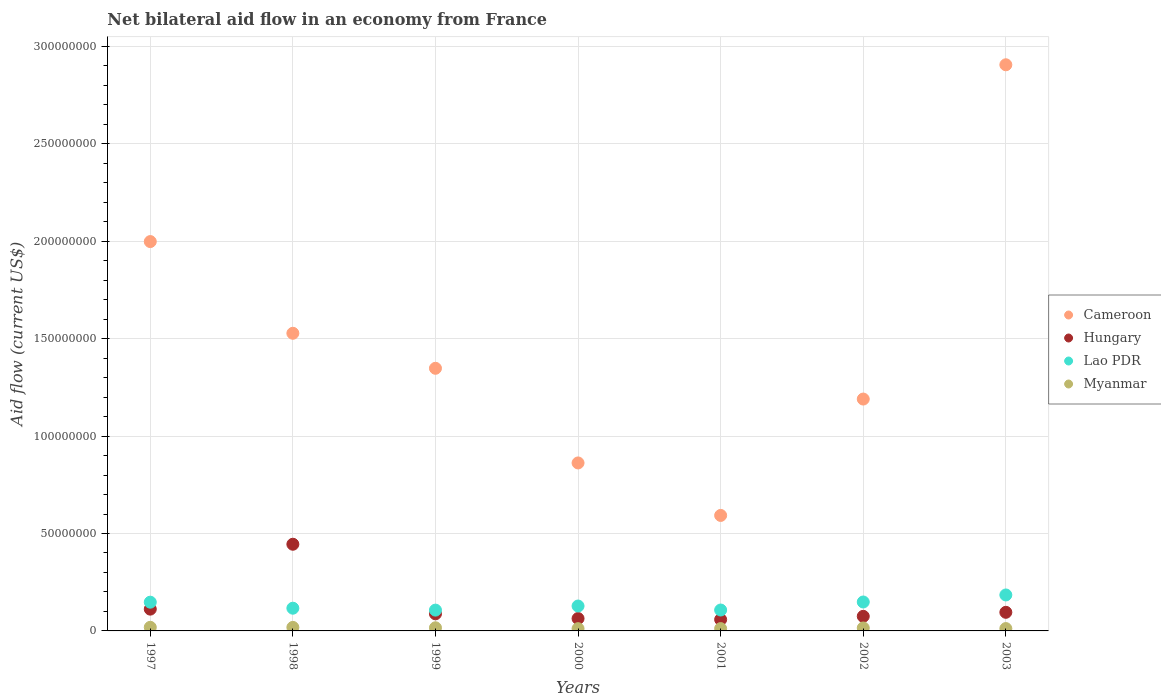How many different coloured dotlines are there?
Your answer should be compact. 4. Is the number of dotlines equal to the number of legend labels?
Your answer should be very brief. Yes. What is the net bilateral aid flow in Cameroon in 2003?
Keep it short and to the point. 2.91e+08. Across all years, what is the maximum net bilateral aid flow in Hungary?
Give a very brief answer. 4.45e+07. Across all years, what is the minimum net bilateral aid flow in Myanmar?
Offer a very short reply. 1.16e+06. What is the total net bilateral aid flow in Lao PDR in the graph?
Make the answer very short. 9.39e+07. What is the difference between the net bilateral aid flow in Hungary in 2001 and that in 2003?
Offer a terse response. -3.71e+06. What is the difference between the net bilateral aid flow in Cameroon in 1998 and the net bilateral aid flow in Hungary in 2000?
Ensure brevity in your answer.  1.46e+08. What is the average net bilateral aid flow in Cameroon per year?
Your answer should be compact. 1.49e+08. In the year 1997, what is the difference between the net bilateral aid flow in Myanmar and net bilateral aid flow in Cameroon?
Provide a short and direct response. -1.98e+08. What is the ratio of the net bilateral aid flow in Hungary in 1997 to that in 2000?
Offer a terse response. 1.76. What is the difference between the highest and the lowest net bilateral aid flow in Cameroon?
Make the answer very short. 2.31e+08. In how many years, is the net bilateral aid flow in Cameroon greater than the average net bilateral aid flow in Cameroon taken over all years?
Give a very brief answer. 3. Is it the case that in every year, the sum of the net bilateral aid flow in Lao PDR and net bilateral aid flow in Cameroon  is greater than the net bilateral aid flow in Myanmar?
Offer a terse response. Yes. Does the net bilateral aid flow in Hungary monotonically increase over the years?
Provide a succinct answer. No. Is the net bilateral aid flow in Lao PDR strictly greater than the net bilateral aid flow in Hungary over the years?
Keep it short and to the point. No. How many dotlines are there?
Keep it short and to the point. 4. Does the graph contain any zero values?
Your answer should be compact. No. Does the graph contain grids?
Make the answer very short. Yes. How many legend labels are there?
Give a very brief answer. 4. What is the title of the graph?
Your answer should be very brief. Net bilateral aid flow in an economy from France. What is the label or title of the X-axis?
Your answer should be very brief. Years. What is the label or title of the Y-axis?
Give a very brief answer. Aid flow (current US$). What is the Aid flow (current US$) in Cameroon in 1997?
Offer a very short reply. 2.00e+08. What is the Aid flow (current US$) of Hungary in 1997?
Provide a short and direct response. 1.12e+07. What is the Aid flow (current US$) in Lao PDR in 1997?
Your answer should be very brief. 1.48e+07. What is the Aid flow (current US$) of Myanmar in 1997?
Offer a terse response. 1.85e+06. What is the Aid flow (current US$) in Cameroon in 1998?
Offer a very short reply. 1.53e+08. What is the Aid flow (current US$) of Hungary in 1998?
Offer a terse response. 4.45e+07. What is the Aid flow (current US$) in Lao PDR in 1998?
Give a very brief answer. 1.17e+07. What is the Aid flow (current US$) in Myanmar in 1998?
Your response must be concise. 1.81e+06. What is the Aid flow (current US$) in Cameroon in 1999?
Your response must be concise. 1.35e+08. What is the Aid flow (current US$) in Hungary in 1999?
Keep it short and to the point. 8.77e+06. What is the Aid flow (current US$) in Lao PDR in 1999?
Provide a short and direct response. 1.07e+07. What is the Aid flow (current US$) in Myanmar in 1999?
Provide a short and direct response. 1.61e+06. What is the Aid flow (current US$) in Cameroon in 2000?
Your answer should be very brief. 8.62e+07. What is the Aid flow (current US$) in Hungary in 2000?
Offer a terse response. 6.36e+06. What is the Aid flow (current US$) of Lao PDR in 2000?
Provide a short and direct response. 1.28e+07. What is the Aid flow (current US$) of Myanmar in 2000?
Provide a short and direct response. 1.16e+06. What is the Aid flow (current US$) in Cameroon in 2001?
Your answer should be compact. 5.93e+07. What is the Aid flow (current US$) in Hungary in 2001?
Ensure brevity in your answer.  5.84e+06. What is the Aid flow (current US$) of Lao PDR in 2001?
Offer a terse response. 1.07e+07. What is the Aid flow (current US$) of Myanmar in 2001?
Offer a terse response. 1.19e+06. What is the Aid flow (current US$) of Cameroon in 2002?
Keep it short and to the point. 1.19e+08. What is the Aid flow (current US$) of Hungary in 2002?
Provide a succinct answer. 7.49e+06. What is the Aid flow (current US$) of Lao PDR in 2002?
Keep it short and to the point. 1.48e+07. What is the Aid flow (current US$) of Myanmar in 2002?
Your response must be concise. 1.52e+06. What is the Aid flow (current US$) of Cameroon in 2003?
Offer a very short reply. 2.91e+08. What is the Aid flow (current US$) of Hungary in 2003?
Give a very brief answer. 9.55e+06. What is the Aid flow (current US$) of Lao PDR in 2003?
Give a very brief answer. 1.85e+07. What is the Aid flow (current US$) of Myanmar in 2003?
Provide a succinct answer. 1.21e+06. Across all years, what is the maximum Aid flow (current US$) in Cameroon?
Keep it short and to the point. 2.91e+08. Across all years, what is the maximum Aid flow (current US$) in Hungary?
Your response must be concise. 4.45e+07. Across all years, what is the maximum Aid flow (current US$) in Lao PDR?
Make the answer very short. 1.85e+07. Across all years, what is the maximum Aid flow (current US$) of Myanmar?
Your response must be concise. 1.85e+06. Across all years, what is the minimum Aid flow (current US$) in Cameroon?
Your answer should be compact. 5.93e+07. Across all years, what is the minimum Aid flow (current US$) in Hungary?
Your response must be concise. 5.84e+06. Across all years, what is the minimum Aid flow (current US$) of Lao PDR?
Your answer should be very brief. 1.07e+07. Across all years, what is the minimum Aid flow (current US$) of Myanmar?
Ensure brevity in your answer.  1.16e+06. What is the total Aid flow (current US$) of Cameroon in the graph?
Offer a very short reply. 1.04e+09. What is the total Aid flow (current US$) in Hungary in the graph?
Your answer should be very brief. 9.37e+07. What is the total Aid flow (current US$) of Lao PDR in the graph?
Offer a terse response. 9.39e+07. What is the total Aid flow (current US$) in Myanmar in the graph?
Ensure brevity in your answer.  1.04e+07. What is the difference between the Aid flow (current US$) in Cameroon in 1997 and that in 1998?
Offer a very short reply. 4.71e+07. What is the difference between the Aid flow (current US$) of Hungary in 1997 and that in 1998?
Your response must be concise. -3.33e+07. What is the difference between the Aid flow (current US$) in Lao PDR in 1997 and that in 1998?
Keep it short and to the point. 3.09e+06. What is the difference between the Aid flow (current US$) in Cameroon in 1997 and that in 1999?
Offer a very short reply. 6.50e+07. What is the difference between the Aid flow (current US$) in Hungary in 1997 and that in 1999?
Offer a terse response. 2.41e+06. What is the difference between the Aid flow (current US$) of Lao PDR in 1997 and that in 1999?
Give a very brief answer. 4.07e+06. What is the difference between the Aid flow (current US$) in Myanmar in 1997 and that in 1999?
Keep it short and to the point. 2.40e+05. What is the difference between the Aid flow (current US$) of Cameroon in 1997 and that in 2000?
Offer a terse response. 1.14e+08. What is the difference between the Aid flow (current US$) of Hungary in 1997 and that in 2000?
Your answer should be very brief. 4.82e+06. What is the difference between the Aid flow (current US$) in Lao PDR in 1997 and that in 2000?
Offer a terse response. 1.97e+06. What is the difference between the Aid flow (current US$) in Myanmar in 1997 and that in 2000?
Make the answer very short. 6.90e+05. What is the difference between the Aid flow (current US$) of Cameroon in 1997 and that in 2001?
Give a very brief answer. 1.41e+08. What is the difference between the Aid flow (current US$) of Hungary in 1997 and that in 2001?
Your answer should be very brief. 5.34e+06. What is the difference between the Aid flow (current US$) of Lao PDR in 1997 and that in 2001?
Provide a succinct answer. 4.02e+06. What is the difference between the Aid flow (current US$) of Myanmar in 1997 and that in 2001?
Give a very brief answer. 6.60e+05. What is the difference between the Aid flow (current US$) of Cameroon in 1997 and that in 2002?
Provide a short and direct response. 8.08e+07. What is the difference between the Aid flow (current US$) in Hungary in 1997 and that in 2002?
Your response must be concise. 3.69e+06. What is the difference between the Aid flow (current US$) of Lao PDR in 1997 and that in 2002?
Keep it short and to the point. -1.00e+05. What is the difference between the Aid flow (current US$) in Cameroon in 1997 and that in 2003?
Your answer should be compact. -9.08e+07. What is the difference between the Aid flow (current US$) of Hungary in 1997 and that in 2003?
Provide a succinct answer. 1.63e+06. What is the difference between the Aid flow (current US$) of Lao PDR in 1997 and that in 2003?
Offer a terse response. -3.71e+06. What is the difference between the Aid flow (current US$) in Myanmar in 1997 and that in 2003?
Your response must be concise. 6.40e+05. What is the difference between the Aid flow (current US$) in Cameroon in 1998 and that in 1999?
Give a very brief answer. 1.80e+07. What is the difference between the Aid flow (current US$) of Hungary in 1998 and that in 1999?
Give a very brief answer. 3.57e+07. What is the difference between the Aid flow (current US$) of Lao PDR in 1998 and that in 1999?
Your answer should be compact. 9.80e+05. What is the difference between the Aid flow (current US$) of Myanmar in 1998 and that in 1999?
Ensure brevity in your answer.  2.00e+05. What is the difference between the Aid flow (current US$) in Cameroon in 1998 and that in 2000?
Provide a succinct answer. 6.66e+07. What is the difference between the Aid flow (current US$) of Hungary in 1998 and that in 2000?
Make the answer very short. 3.81e+07. What is the difference between the Aid flow (current US$) in Lao PDR in 1998 and that in 2000?
Provide a short and direct response. -1.12e+06. What is the difference between the Aid flow (current US$) in Myanmar in 1998 and that in 2000?
Offer a very short reply. 6.50e+05. What is the difference between the Aid flow (current US$) in Cameroon in 1998 and that in 2001?
Offer a very short reply. 9.35e+07. What is the difference between the Aid flow (current US$) of Hungary in 1998 and that in 2001?
Keep it short and to the point. 3.86e+07. What is the difference between the Aid flow (current US$) of Lao PDR in 1998 and that in 2001?
Your answer should be compact. 9.30e+05. What is the difference between the Aid flow (current US$) in Myanmar in 1998 and that in 2001?
Give a very brief answer. 6.20e+05. What is the difference between the Aid flow (current US$) of Cameroon in 1998 and that in 2002?
Give a very brief answer. 3.38e+07. What is the difference between the Aid flow (current US$) of Hungary in 1998 and that in 2002?
Keep it short and to the point. 3.70e+07. What is the difference between the Aid flow (current US$) in Lao PDR in 1998 and that in 2002?
Offer a terse response. -3.19e+06. What is the difference between the Aid flow (current US$) of Myanmar in 1998 and that in 2002?
Keep it short and to the point. 2.90e+05. What is the difference between the Aid flow (current US$) in Cameroon in 1998 and that in 2003?
Your response must be concise. -1.38e+08. What is the difference between the Aid flow (current US$) in Hungary in 1998 and that in 2003?
Make the answer very short. 3.49e+07. What is the difference between the Aid flow (current US$) in Lao PDR in 1998 and that in 2003?
Offer a very short reply. -6.80e+06. What is the difference between the Aid flow (current US$) of Cameroon in 1999 and that in 2000?
Provide a short and direct response. 4.86e+07. What is the difference between the Aid flow (current US$) in Hungary in 1999 and that in 2000?
Keep it short and to the point. 2.41e+06. What is the difference between the Aid flow (current US$) in Lao PDR in 1999 and that in 2000?
Your answer should be compact. -2.10e+06. What is the difference between the Aid flow (current US$) in Myanmar in 1999 and that in 2000?
Offer a very short reply. 4.50e+05. What is the difference between the Aid flow (current US$) of Cameroon in 1999 and that in 2001?
Your answer should be compact. 7.55e+07. What is the difference between the Aid flow (current US$) in Hungary in 1999 and that in 2001?
Keep it short and to the point. 2.93e+06. What is the difference between the Aid flow (current US$) of Cameroon in 1999 and that in 2002?
Your answer should be very brief. 1.58e+07. What is the difference between the Aid flow (current US$) of Hungary in 1999 and that in 2002?
Keep it short and to the point. 1.28e+06. What is the difference between the Aid flow (current US$) of Lao PDR in 1999 and that in 2002?
Keep it short and to the point. -4.17e+06. What is the difference between the Aid flow (current US$) in Cameroon in 1999 and that in 2003?
Keep it short and to the point. -1.56e+08. What is the difference between the Aid flow (current US$) of Hungary in 1999 and that in 2003?
Your response must be concise. -7.80e+05. What is the difference between the Aid flow (current US$) of Lao PDR in 1999 and that in 2003?
Offer a very short reply. -7.78e+06. What is the difference between the Aid flow (current US$) of Myanmar in 1999 and that in 2003?
Offer a very short reply. 4.00e+05. What is the difference between the Aid flow (current US$) in Cameroon in 2000 and that in 2001?
Your answer should be compact. 2.69e+07. What is the difference between the Aid flow (current US$) in Hungary in 2000 and that in 2001?
Your answer should be compact. 5.20e+05. What is the difference between the Aid flow (current US$) of Lao PDR in 2000 and that in 2001?
Give a very brief answer. 2.05e+06. What is the difference between the Aid flow (current US$) in Cameroon in 2000 and that in 2002?
Provide a short and direct response. -3.28e+07. What is the difference between the Aid flow (current US$) of Hungary in 2000 and that in 2002?
Ensure brevity in your answer.  -1.13e+06. What is the difference between the Aid flow (current US$) of Lao PDR in 2000 and that in 2002?
Your answer should be very brief. -2.07e+06. What is the difference between the Aid flow (current US$) of Myanmar in 2000 and that in 2002?
Provide a succinct answer. -3.60e+05. What is the difference between the Aid flow (current US$) of Cameroon in 2000 and that in 2003?
Keep it short and to the point. -2.04e+08. What is the difference between the Aid flow (current US$) in Hungary in 2000 and that in 2003?
Provide a short and direct response. -3.19e+06. What is the difference between the Aid flow (current US$) of Lao PDR in 2000 and that in 2003?
Provide a short and direct response. -5.68e+06. What is the difference between the Aid flow (current US$) in Cameroon in 2001 and that in 2002?
Keep it short and to the point. -5.97e+07. What is the difference between the Aid flow (current US$) in Hungary in 2001 and that in 2002?
Ensure brevity in your answer.  -1.65e+06. What is the difference between the Aid flow (current US$) of Lao PDR in 2001 and that in 2002?
Your response must be concise. -4.12e+06. What is the difference between the Aid flow (current US$) in Myanmar in 2001 and that in 2002?
Offer a terse response. -3.30e+05. What is the difference between the Aid flow (current US$) in Cameroon in 2001 and that in 2003?
Offer a very short reply. -2.31e+08. What is the difference between the Aid flow (current US$) in Hungary in 2001 and that in 2003?
Your answer should be very brief. -3.71e+06. What is the difference between the Aid flow (current US$) of Lao PDR in 2001 and that in 2003?
Provide a succinct answer. -7.73e+06. What is the difference between the Aid flow (current US$) of Myanmar in 2001 and that in 2003?
Provide a short and direct response. -2.00e+04. What is the difference between the Aid flow (current US$) in Cameroon in 2002 and that in 2003?
Your answer should be compact. -1.72e+08. What is the difference between the Aid flow (current US$) of Hungary in 2002 and that in 2003?
Offer a terse response. -2.06e+06. What is the difference between the Aid flow (current US$) in Lao PDR in 2002 and that in 2003?
Ensure brevity in your answer.  -3.61e+06. What is the difference between the Aid flow (current US$) in Cameroon in 1997 and the Aid flow (current US$) in Hungary in 1998?
Provide a succinct answer. 1.55e+08. What is the difference between the Aid flow (current US$) of Cameroon in 1997 and the Aid flow (current US$) of Lao PDR in 1998?
Offer a terse response. 1.88e+08. What is the difference between the Aid flow (current US$) of Cameroon in 1997 and the Aid flow (current US$) of Myanmar in 1998?
Offer a very short reply. 1.98e+08. What is the difference between the Aid flow (current US$) of Hungary in 1997 and the Aid flow (current US$) of Lao PDR in 1998?
Your response must be concise. -4.80e+05. What is the difference between the Aid flow (current US$) in Hungary in 1997 and the Aid flow (current US$) in Myanmar in 1998?
Your answer should be compact. 9.37e+06. What is the difference between the Aid flow (current US$) of Lao PDR in 1997 and the Aid flow (current US$) of Myanmar in 1998?
Give a very brief answer. 1.29e+07. What is the difference between the Aid flow (current US$) in Cameroon in 1997 and the Aid flow (current US$) in Hungary in 1999?
Provide a succinct answer. 1.91e+08. What is the difference between the Aid flow (current US$) in Cameroon in 1997 and the Aid flow (current US$) in Lao PDR in 1999?
Provide a short and direct response. 1.89e+08. What is the difference between the Aid flow (current US$) in Cameroon in 1997 and the Aid flow (current US$) in Myanmar in 1999?
Offer a terse response. 1.98e+08. What is the difference between the Aid flow (current US$) in Hungary in 1997 and the Aid flow (current US$) in Myanmar in 1999?
Make the answer very short. 9.57e+06. What is the difference between the Aid flow (current US$) of Lao PDR in 1997 and the Aid flow (current US$) of Myanmar in 1999?
Offer a terse response. 1.31e+07. What is the difference between the Aid flow (current US$) of Cameroon in 1997 and the Aid flow (current US$) of Hungary in 2000?
Offer a very short reply. 1.93e+08. What is the difference between the Aid flow (current US$) of Cameroon in 1997 and the Aid flow (current US$) of Lao PDR in 2000?
Provide a short and direct response. 1.87e+08. What is the difference between the Aid flow (current US$) of Cameroon in 1997 and the Aid flow (current US$) of Myanmar in 2000?
Your answer should be compact. 1.99e+08. What is the difference between the Aid flow (current US$) of Hungary in 1997 and the Aid flow (current US$) of Lao PDR in 2000?
Your answer should be compact. -1.60e+06. What is the difference between the Aid flow (current US$) of Hungary in 1997 and the Aid flow (current US$) of Myanmar in 2000?
Offer a very short reply. 1.00e+07. What is the difference between the Aid flow (current US$) in Lao PDR in 1997 and the Aid flow (current US$) in Myanmar in 2000?
Your response must be concise. 1.36e+07. What is the difference between the Aid flow (current US$) of Cameroon in 1997 and the Aid flow (current US$) of Hungary in 2001?
Make the answer very short. 1.94e+08. What is the difference between the Aid flow (current US$) in Cameroon in 1997 and the Aid flow (current US$) in Lao PDR in 2001?
Ensure brevity in your answer.  1.89e+08. What is the difference between the Aid flow (current US$) in Cameroon in 1997 and the Aid flow (current US$) in Myanmar in 2001?
Your answer should be very brief. 1.99e+08. What is the difference between the Aid flow (current US$) in Hungary in 1997 and the Aid flow (current US$) in Lao PDR in 2001?
Your response must be concise. 4.50e+05. What is the difference between the Aid flow (current US$) of Hungary in 1997 and the Aid flow (current US$) of Myanmar in 2001?
Your answer should be compact. 9.99e+06. What is the difference between the Aid flow (current US$) in Lao PDR in 1997 and the Aid flow (current US$) in Myanmar in 2001?
Give a very brief answer. 1.36e+07. What is the difference between the Aid flow (current US$) of Cameroon in 1997 and the Aid flow (current US$) of Hungary in 2002?
Your answer should be very brief. 1.92e+08. What is the difference between the Aid flow (current US$) of Cameroon in 1997 and the Aid flow (current US$) of Lao PDR in 2002?
Make the answer very short. 1.85e+08. What is the difference between the Aid flow (current US$) of Cameroon in 1997 and the Aid flow (current US$) of Myanmar in 2002?
Your answer should be very brief. 1.98e+08. What is the difference between the Aid flow (current US$) of Hungary in 1997 and the Aid flow (current US$) of Lao PDR in 2002?
Provide a short and direct response. -3.67e+06. What is the difference between the Aid flow (current US$) in Hungary in 1997 and the Aid flow (current US$) in Myanmar in 2002?
Offer a very short reply. 9.66e+06. What is the difference between the Aid flow (current US$) of Lao PDR in 1997 and the Aid flow (current US$) of Myanmar in 2002?
Provide a short and direct response. 1.32e+07. What is the difference between the Aid flow (current US$) in Cameroon in 1997 and the Aid flow (current US$) in Hungary in 2003?
Make the answer very short. 1.90e+08. What is the difference between the Aid flow (current US$) in Cameroon in 1997 and the Aid flow (current US$) in Lao PDR in 2003?
Keep it short and to the point. 1.81e+08. What is the difference between the Aid flow (current US$) in Cameroon in 1997 and the Aid flow (current US$) in Myanmar in 2003?
Ensure brevity in your answer.  1.99e+08. What is the difference between the Aid flow (current US$) in Hungary in 1997 and the Aid flow (current US$) in Lao PDR in 2003?
Ensure brevity in your answer.  -7.28e+06. What is the difference between the Aid flow (current US$) in Hungary in 1997 and the Aid flow (current US$) in Myanmar in 2003?
Make the answer very short. 9.97e+06. What is the difference between the Aid flow (current US$) in Lao PDR in 1997 and the Aid flow (current US$) in Myanmar in 2003?
Ensure brevity in your answer.  1.35e+07. What is the difference between the Aid flow (current US$) in Cameroon in 1998 and the Aid flow (current US$) in Hungary in 1999?
Your answer should be compact. 1.44e+08. What is the difference between the Aid flow (current US$) in Cameroon in 1998 and the Aid flow (current US$) in Lao PDR in 1999?
Keep it short and to the point. 1.42e+08. What is the difference between the Aid flow (current US$) in Cameroon in 1998 and the Aid flow (current US$) in Myanmar in 1999?
Your response must be concise. 1.51e+08. What is the difference between the Aid flow (current US$) of Hungary in 1998 and the Aid flow (current US$) of Lao PDR in 1999?
Your answer should be very brief. 3.38e+07. What is the difference between the Aid flow (current US$) in Hungary in 1998 and the Aid flow (current US$) in Myanmar in 1999?
Offer a very short reply. 4.29e+07. What is the difference between the Aid flow (current US$) in Lao PDR in 1998 and the Aid flow (current US$) in Myanmar in 1999?
Give a very brief answer. 1.00e+07. What is the difference between the Aid flow (current US$) of Cameroon in 1998 and the Aid flow (current US$) of Hungary in 2000?
Make the answer very short. 1.46e+08. What is the difference between the Aid flow (current US$) of Cameroon in 1998 and the Aid flow (current US$) of Lao PDR in 2000?
Ensure brevity in your answer.  1.40e+08. What is the difference between the Aid flow (current US$) in Cameroon in 1998 and the Aid flow (current US$) in Myanmar in 2000?
Your answer should be very brief. 1.52e+08. What is the difference between the Aid flow (current US$) of Hungary in 1998 and the Aid flow (current US$) of Lao PDR in 2000?
Provide a succinct answer. 3.17e+07. What is the difference between the Aid flow (current US$) of Hungary in 1998 and the Aid flow (current US$) of Myanmar in 2000?
Your response must be concise. 4.33e+07. What is the difference between the Aid flow (current US$) of Lao PDR in 1998 and the Aid flow (current US$) of Myanmar in 2000?
Your answer should be very brief. 1.05e+07. What is the difference between the Aid flow (current US$) in Cameroon in 1998 and the Aid flow (current US$) in Hungary in 2001?
Your answer should be compact. 1.47e+08. What is the difference between the Aid flow (current US$) in Cameroon in 1998 and the Aid flow (current US$) in Lao PDR in 2001?
Keep it short and to the point. 1.42e+08. What is the difference between the Aid flow (current US$) in Cameroon in 1998 and the Aid flow (current US$) in Myanmar in 2001?
Offer a terse response. 1.52e+08. What is the difference between the Aid flow (current US$) in Hungary in 1998 and the Aid flow (current US$) in Lao PDR in 2001?
Your answer should be compact. 3.38e+07. What is the difference between the Aid flow (current US$) in Hungary in 1998 and the Aid flow (current US$) in Myanmar in 2001?
Offer a very short reply. 4.33e+07. What is the difference between the Aid flow (current US$) in Lao PDR in 1998 and the Aid flow (current US$) in Myanmar in 2001?
Make the answer very short. 1.05e+07. What is the difference between the Aid flow (current US$) in Cameroon in 1998 and the Aid flow (current US$) in Hungary in 2002?
Make the answer very short. 1.45e+08. What is the difference between the Aid flow (current US$) of Cameroon in 1998 and the Aid flow (current US$) of Lao PDR in 2002?
Provide a short and direct response. 1.38e+08. What is the difference between the Aid flow (current US$) of Cameroon in 1998 and the Aid flow (current US$) of Myanmar in 2002?
Provide a short and direct response. 1.51e+08. What is the difference between the Aid flow (current US$) in Hungary in 1998 and the Aid flow (current US$) in Lao PDR in 2002?
Ensure brevity in your answer.  2.96e+07. What is the difference between the Aid flow (current US$) of Hungary in 1998 and the Aid flow (current US$) of Myanmar in 2002?
Keep it short and to the point. 4.30e+07. What is the difference between the Aid flow (current US$) in Lao PDR in 1998 and the Aid flow (current US$) in Myanmar in 2002?
Your answer should be very brief. 1.01e+07. What is the difference between the Aid flow (current US$) of Cameroon in 1998 and the Aid flow (current US$) of Hungary in 2003?
Your answer should be very brief. 1.43e+08. What is the difference between the Aid flow (current US$) of Cameroon in 1998 and the Aid flow (current US$) of Lao PDR in 2003?
Your answer should be very brief. 1.34e+08. What is the difference between the Aid flow (current US$) of Cameroon in 1998 and the Aid flow (current US$) of Myanmar in 2003?
Provide a short and direct response. 1.52e+08. What is the difference between the Aid flow (current US$) of Hungary in 1998 and the Aid flow (current US$) of Lao PDR in 2003?
Offer a terse response. 2.60e+07. What is the difference between the Aid flow (current US$) in Hungary in 1998 and the Aid flow (current US$) in Myanmar in 2003?
Give a very brief answer. 4.33e+07. What is the difference between the Aid flow (current US$) of Lao PDR in 1998 and the Aid flow (current US$) of Myanmar in 2003?
Ensure brevity in your answer.  1.04e+07. What is the difference between the Aid flow (current US$) in Cameroon in 1999 and the Aid flow (current US$) in Hungary in 2000?
Give a very brief answer. 1.28e+08. What is the difference between the Aid flow (current US$) in Cameroon in 1999 and the Aid flow (current US$) in Lao PDR in 2000?
Keep it short and to the point. 1.22e+08. What is the difference between the Aid flow (current US$) in Cameroon in 1999 and the Aid flow (current US$) in Myanmar in 2000?
Ensure brevity in your answer.  1.34e+08. What is the difference between the Aid flow (current US$) in Hungary in 1999 and the Aid flow (current US$) in Lao PDR in 2000?
Ensure brevity in your answer.  -4.01e+06. What is the difference between the Aid flow (current US$) in Hungary in 1999 and the Aid flow (current US$) in Myanmar in 2000?
Your answer should be very brief. 7.61e+06. What is the difference between the Aid flow (current US$) of Lao PDR in 1999 and the Aid flow (current US$) of Myanmar in 2000?
Give a very brief answer. 9.52e+06. What is the difference between the Aid flow (current US$) of Cameroon in 1999 and the Aid flow (current US$) of Hungary in 2001?
Provide a succinct answer. 1.29e+08. What is the difference between the Aid flow (current US$) of Cameroon in 1999 and the Aid flow (current US$) of Lao PDR in 2001?
Provide a short and direct response. 1.24e+08. What is the difference between the Aid flow (current US$) of Cameroon in 1999 and the Aid flow (current US$) of Myanmar in 2001?
Ensure brevity in your answer.  1.34e+08. What is the difference between the Aid flow (current US$) in Hungary in 1999 and the Aid flow (current US$) in Lao PDR in 2001?
Keep it short and to the point. -1.96e+06. What is the difference between the Aid flow (current US$) of Hungary in 1999 and the Aid flow (current US$) of Myanmar in 2001?
Offer a very short reply. 7.58e+06. What is the difference between the Aid flow (current US$) of Lao PDR in 1999 and the Aid flow (current US$) of Myanmar in 2001?
Offer a very short reply. 9.49e+06. What is the difference between the Aid flow (current US$) of Cameroon in 1999 and the Aid flow (current US$) of Hungary in 2002?
Make the answer very short. 1.27e+08. What is the difference between the Aid flow (current US$) in Cameroon in 1999 and the Aid flow (current US$) in Lao PDR in 2002?
Offer a very short reply. 1.20e+08. What is the difference between the Aid flow (current US$) of Cameroon in 1999 and the Aid flow (current US$) of Myanmar in 2002?
Give a very brief answer. 1.33e+08. What is the difference between the Aid flow (current US$) in Hungary in 1999 and the Aid flow (current US$) in Lao PDR in 2002?
Keep it short and to the point. -6.08e+06. What is the difference between the Aid flow (current US$) of Hungary in 1999 and the Aid flow (current US$) of Myanmar in 2002?
Offer a terse response. 7.25e+06. What is the difference between the Aid flow (current US$) in Lao PDR in 1999 and the Aid flow (current US$) in Myanmar in 2002?
Ensure brevity in your answer.  9.16e+06. What is the difference between the Aid flow (current US$) in Cameroon in 1999 and the Aid flow (current US$) in Hungary in 2003?
Provide a succinct answer. 1.25e+08. What is the difference between the Aid flow (current US$) of Cameroon in 1999 and the Aid flow (current US$) of Lao PDR in 2003?
Offer a terse response. 1.16e+08. What is the difference between the Aid flow (current US$) in Cameroon in 1999 and the Aid flow (current US$) in Myanmar in 2003?
Keep it short and to the point. 1.34e+08. What is the difference between the Aid flow (current US$) of Hungary in 1999 and the Aid flow (current US$) of Lao PDR in 2003?
Your answer should be compact. -9.69e+06. What is the difference between the Aid flow (current US$) in Hungary in 1999 and the Aid flow (current US$) in Myanmar in 2003?
Your answer should be very brief. 7.56e+06. What is the difference between the Aid flow (current US$) of Lao PDR in 1999 and the Aid flow (current US$) of Myanmar in 2003?
Your answer should be very brief. 9.47e+06. What is the difference between the Aid flow (current US$) in Cameroon in 2000 and the Aid flow (current US$) in Hungary in 2001?
Your answer should be very brief. 8.04e+07. What is the difference between the Aid flow (current US$) of Cameroon in 2000 and the Aid flow (current US$) of Lao PDR in 2001?
Your answer should be compact. 7.55e+07. What is the difference between the Aid flow (current US$) of Cameroon in 2000 and the Aid flow (current US$) of Myanmar in 2001?
Make the answer very short. 8.50e+07. What is the difference between the Aid flow (current US$) in Hungary in 2000 and the Aid flow (current US$) in Lao PDR in 2001?
Offer a very short reply. -4.37e+06. What is the difference between the Aid flow (current US$) of Hungary in 2000 and the Aid flow (current US$) of Myanmar in 2001?
Make the answer very short. 5.17e+06. What is the difference between the Aid flow (current US$) of Lao PDR in 2000 and the Aid flow (current US$) of Myanmar in 2001?
Provide a short and direct response. 1.16e+07. What is the difference between the Aid flow (current US$) in Cameroon in 2000 and the Aid flow (current US$) in Hungary in 2002?
Make the answer very short. 7.87e+07. What is the difference between the Aid flow (current US$) of Cameroon in 2000 and the Aid flow (current US$) of Lao PDR in 2002?
Offer a very short reply. 7.14e+07. What is the difference between the Aid flow (current US$) of Cameroon in 2000 and the Aid flow (current US$) of Myanmar in 2002?
Ensure brevity in your answer.  8.47e+07. What is the difference between the Aid flow (current US$) in Hungary in 2000 and the Aid flow (current US$) in Lao PDR in 2002?
Provide a succinct answer. -8.49e+06. What is the difference between the Aid flow (current US$) of Hungary in 2000 and the Aid flow (current US$) of Myanmar in 2002?
Make the answer very short. 4.84e+06. What is the difference between the Aid flow (current US$) of Lao PDR in 2000 and the Aid flow (current US$) of Myanmar in 2002?
Your answer should be compact. 1.13e+07. What is the difference between the Aid flow (current US$) of Cameroon in 2000 and the Aid flow (current US$) of Hungary in 2003?
Offer a terse response. 7.67e+07. What is the difference between the Aid flow (current US$) of Cameroon in 2000 and the Aid flow (current US$) of Lao PDR in 2003?
Keep it short and to the point. 6.78e+07. What is the difference between the Aid flow (current US$) in Cameroon in 2000 and the Aid flow (current US$) in Myanmar in 2003?
Ensure brevity in your answer.  8.50e+07. What is the difference between the Aid flow (current US$) in Hungary in 2000 and the Aid flow (current US$) in Lao PDR in 2003?
Give a very brief answer. -1.21e+07. What is the difference between the Aid flow (current US$) in Hungary in 2000 and the Aid flow (current US$) in Myanmar in 2003?
Offer a terse response. 5.15e+06. What is the difference between the Aid flow (current US$) of Lao PDR in 2000 and the Aid flow (current US$) of Myanmar in 2003?
Provide a succinct answer. 1.16e+07. What is the difference between the Aid flow (current US$) of Cameroon in 2001 and the Aid flow (current US$) of Hungary in 2002?
Keep it short and to the point. 5.18e+07. What is the difference between the Aid flow (current US$) of Cameroon in 2001 and the Aid flow (current US$) of Lao PDR in 2002?
Ensure brevity in your answer.  4.44e+07. What is the difference between the Aid flow (current US$) of Cameroon in 2001 and the Aid flow (current US$) of Myanmar in 2002?
Your answer should be compact. 5.78e+07. What is the difference between the Aid flow (current US$) of Hungary in 2001 and the Aid flow (current US$) of Lao PDR in 2002?
Your response must be concise. -9.01e+06. What is the difference between the Aid flow (current US$) of Hungary in 2001 and the Aid flow (current US$) of Myanmar in 2002?
Offer a very short reply. 4.32e+06. What is the difference between the Aid flow (current US$) in Lao PDR in 2001 and the Aid flow (current US$) in Myanmar in 2002?
Your answer should be very brief. 9.21e+06. What is the difference between the Aid flow (current US$) in Cameroon in 2001 and the Aid flow (current US$) in Hungary in 2003?
Provide a short and direct response. 4.97e+07. What is the difference between the Aid flow (current US$) in Cameroon in 2001 and the Aid flow (current US$) in Lao PDR in 2003?
Your answer should be compact. 4.08e+07. What is the difference between the Aid flow (current US$) of Cameroon in 2001 and the Aid flow (current US$) of Myanmar in 2003?
Your answer should be compact. 5.81e+07. What is the difference between the Aid flow (current US$) of Hungary in 2001 and the Aid flow (current US$) of Lao PDR in 2003?
Your response must be concise. -1.26e+07. What is the difference between the Aid flow (current US$) of Hungary in 2001 and the Aid flow (current US$) of Myanmar in 2003?
Give a very brief answer. 4.63e+06. What is the difference between the Aid flow (current US$) of Lao PDR in 2001 and the Aid flow (current US$) of Myanmar in 2003?
Provide a short and direct response. 9.52e+06. What is the difference between the Aid flow (current US$) of Cameroon in 2002 and the Aid flow (current US$) of Hungary in 2003?
Offer a terse response. 1.09e+08. What is the difference between the Aid flow (current US$) of Cameroon in 2002 and the Aid flow (current US$) of Lao PDR in 2003?
Ensure brevity in your answer.  1.01e+08. What is the difference between the Aid flow (current US$) in Cameroon in 2002 and the Aid flow (current US$) in Myanmar in 2003?
Give a very brief answer. 1.18e+08. What is the difference between the Aid flow (current US$) of Hungary in 2002 and the Aid flow (current US$) of Lao PDR in 2003?
Ensure brevity in your answer.  -1.10e+07. What is the difference between the Aid flow (current US$) of Hungary in 2002 and the Aid flow (current US$) of Myanmar in 2003?
Give a very brief answer. 6.28e+06. What is the difference between the Aid flow (current US$) in Lao PDR in 2002 and the Aid flow (current US$) in Myanmar in 2003?
Your response must be concise. 1.36e+07. What is the average Aid flow (current US$) of Cameroon per year?
Provide a short and direct response. 1.49e+08. What is the average Aid flow (current US$) in Hungary per year?
Keep it short and to the point. 1.34e+07. What is the average Aid flow (current US$) of Lao PDR per year?
Your answer should be compact. 1.34e+07. What is the average Aid flow (current US$) in Myanmar per year?
Offer a terse response. 1.48e+06. In the year 1997, what is the difference between the Aid flow (current US$) of Cameroon and Aid flow (current US$) of Hungary?
Keep it short and to the point. 1.89e+08. In the year 1997, what is the difference between the Aid flow (current US$) in Cameroon and Aid flow (current US$) in Lao PDR?
Provide a short and direct response. 1.85e+08. In the year 1997, what is the difference between the Aid flow (current US$) of Cameroon and Aid flow (current US$) of Myanmar?
Offer a terse response. 1.98e+08. In the year 1997, what is the difference between the Aid flow (current US$) in Hungary and Aid flow (current US$) in Lao PDR?
Provide a succinct answer. -3.57e+06. In the year 1997, what is the difference between the Aid flow (current US$) of Hungary and Aid flow (current US$) of Myanmar?
Your answer should be very brief. 9.33e+06. In the year 1997, what is the difference between the Aid flow (current US$) of Lao PDR and Aid flow (current US$) of Myanmar?
Make the answer very short. 1.29e+07. In the year 1998, what is the difference between the Aid flow (current US$) of Cameroon and Aid flow (current US$) of Hungary?
Ensure brevity in your answer.  1.08e+08. In the year 1998, what is the difference between the Aid flow (current US$) in Cameroon and Aid flow (current US$) in Lao PDR?
Your answer should be compact. 1.41e+08. In the year 1998, what is the difference between the Aid flow (current US$) of Cameroon and Aid flow (current US$) of Myanmar?
Give a very brief answer. 1.51e+08. In the year 1998, what is the difference between the Aid flow (current US$) of Hungary and Aid flow (current US$) of Lao PDR?
Your answer should be compact. 3.28e+07. In the year 1998, what is the difference between the Aid flow (current US$) of Hungary and Aid flow (current US$) of Myanmar?
Provide a short and direct response. 4.27e+07. In the year 1998, what is the difference between the Aid flow (current US$) in Lao PDR and Aid flow (current US$) in Myanmar?
Your answer should be very brief. 9.85e+06. In the year 1999, what is the difference between the Aid flow (current US$) of Cameroon and Aid flow (current US$) of Hungary?
Your response must be concise. 1.26e+08. In the year 1999, what is the difference between the Aid flow (current US$) in Cameroon and Aid flow (current US$) in Lao PDR?
Your answer should be very brief. 1.24e+08. In the year 1999, what is the difference between the Aid flow (current US$) in Cameroon and Aid flow (current US$) in Myanmar?
Make the answer very short. 1.33e+08. In the year 1999, what is the difference between the Aid flow (current US$) in Hungary and Aid flow (current US$) in Lao PDR?
Offer a very short reply. -1.91e+06. In the year 1999, what is the difference between the Aid flow (current US$) of Hungary and Aid flow (current US$) of Myanmar?
Offer a terse response. 7.16e+06. In the year 1999, what is the difference between the Aid flow (current US$) of Lao PDR and Aid flow (current US$) of Myanmar?
Provide a short and direct response. 9.07e+06. In the year 2000, what is the difference between the Aid flow (current US$) of Cameroon and Aid flow (current US$) of Hungary?
Make the answer very short. 7.99e+07. In the year 2000, what is the difference between the Aid flow (current US$) of Cameroon and Aid flow (current US$) of Lao PDR?
Give a very brief answer. 7.34e+07. In the year 2000, what is the difference between the Aid flow (current US$) in Cameroon and Aid flow (current US$) in Myanmar?
Offer a very short reply. 8.51e+07. In the year 2000, what is the difference between the Aid flow (current US$) of Hungary and Aid flow (current US$) of Lao PDR?
Your answer should be compact. -6.42e+06. In the year 2000, what is the difference between the Aid flow (current US$) in Hungary and Aid flow (current US$) in Myanmar?
Provide a succinct answer. 5.20e+06. In the year 2000, what is the difference between the Aid flow (current US$) of Lao PDR and Aid flow (current US$) of Myanmar?
Your response must be concise. 1.16e+07. In the year 2001, what is the difference between the Aid flow (current US$) of Cameroon and Aid flow (current US$) of Hungary?
Your response must be concise. 5.34e+07. In the year 2001, what is the difference between the Aid flow (current US$) in Cameroon and Aid flow (current US$) in Lao PDR?
Offer a very short reply. 4.86e+07. In the year 2001, what is the difference between the Aid flow (current US$) of Cameroon and Aid flow (current US$) of Myanmar?
Your answer should be very brief. 5.81e+07. In the year 2001, what is the difference between the Aid flow (current US$) in Hungary and Aid flow (current US$) in Lao PDR?
Your answer should be very brief. -4.89e+06. In the year 2001, what is the difference between the Aid flow (current US$) of Hungary and Aid flow (current US$) of Myanmar?
Your answer should be compact. 4.65e+06. In the year 2001, what is the difference between the Aid flow (current US$) in Lao PDR and Aid flow (current US$) in Myanmar?
Keep it short and to the point. 9.54e+06. In the year 2002, what is the difference between the Aid flow (current US$) in Cameroon and Aid flow (current US$) in Hungary?
Provide a succinct answer. 1.12e+08. In the year 2002, what is the difference between the Aid flow (current US$) in Cameroon and Aid flow (current US$) in Lao PDR?
Your answer should be very brief. 1.04e+08. In the year 2002, what is the difference between the Aid flow (current US$) in Cameroon and Aid flow (current US$) in Myanmar?
Your answer should be compact. 1.17e+08. In the year 2002, what is the difference between the Aid flow (current US$) in Hungary and Aid flow (current US$) in Lao PDR?
Your answer should be compact. -7.36e+06. In the year 2002, what is the difference between the Aid flow (current US$) in Hungary and Aid flow (current US$) in Myanmar?
Give a very brief answer. 5.97e+06. In the year 2002, what is the difference between the Aid flow (current US$) in Lao PDR and Aid flow (current US$) in Myanmar?
Provide a short and direct response. 1.33e+07. In the year 2003, what is the difference between the Aid flow (current US$) of Cameroon and Aid flow (current US$) of Hungary?
Your answer should be very brief. 2.81e+08. In the year 2003, what is the difference between the Aid flow (current US$) in Cameroon and Aid flow (current US$) in Lao PDR?
Your response must be concise. 2.72e+08. In the year 2003, what is the difference between the Aid flow (current US$) in Cameroon and Aid flow (current US$) in Myanmar?
Offer a very short reply. 2.89e+08. In the year 2003, what is the difference between the Aid flow (current US$) in Hungary and Aid flow (current US$) in Lao PDR?
Offer a terse response. -8.91e+06. In the year 2003, what is the difference between the Aid flow (current US$) in Hungary and Aid flow (current US$) in Myanmar?
Your answer should be compact. 8.34e+06. In the year 2003, what is the difference between the Aid flow (current US$) in Lao PDR and Aid flow (current US$) in Myanmar?
Your answer should be compact. 1.72e+07. What is the ratio of the Aid flow (current US$) of Cameroon in 1997 to that in 1998?
Offer a terse response. 1.31. What is the ratio of the Aid flow (current US$) in Hungary in 1997 to that in 1998?
Ensure brevity in your answer.  0.25. What is the ratio of the Aid flow (current US$) in Lao PDR in 1997 to that in 1998?
Your answer should be very brief. 1.26. What is the ratio of the Aid flow (current US$) in Myanmar in 1997 to that in 1998?
Your answer should be compact. 1.02. What is the ratio of the Aid flow (current US$) of Cameroon in 1997 to that in 1999?
Give a very brief answer. 1.48. What is the ratio of the Aid flow (current US$) of Hungary in 1997 to that in 1999?
Your answer should be compact. 1.27. What is the ratio of the Aid flow (current US$) in Lao PDR in 1997 to that in 1999?
Ensure brevity in your answer.  1.38. What is the ratio of the Aid flow (current US$) of Myanmar in 1997 to that in 1999?
Provide a short and direct response. 1.15. What is the ratio of the Aid flow (current US$) in Cameroon in 1997 to that in 2000?
Give a very brief answer. 2.32. What is the ratio of the Aid flow (current US$) of Hungary in 1997 to that in 2000?
Keep it short and to the point. 1.76. What is the ratio of the Aid flow (current US$) of Lao PDR in 1997 to that in 2000?
Your response must be concise. 1.15. What is the ratio of the Aid flow (current US$) in Myanmar in 1997 to that in 2000?
Provide a succinct answer. 1.59. What is the ratio of the Aid flow (current US$) in Cameroon in 1997 to that in 2001?
Keep it short and to the point. 3.37. What is the ratio of the Aid flow (current US$) of Hungary in 1997 to that in 2001?
Ensure brevity in your answer.  1.91. What is the ratio of the Aid flow (current US$) in Lao PDR in 1997 to that in 2001?
Make the answer very short. 1.37. What is the ratio of the Aid flow (current US$) of Myanmar in 1997 to that in 2001?
Your answer should be compact. 1.55. What is the ratio of the Aid flow (current US$) in Cameroon in 1997 to that in 2002?
Keep it short and to the point. 1.68. What is the ratio of the Aid flow (current US$) of Hungary in 1997 to that in 2002?
Ensure brevity in your answer.  1.49. What is the ratio of the Aid flow (current US$) of Lao PDR in 1997 to that in 2002?
Your answer should be compact. 0.99. What is the ratio of the Aid flow (current US$) of Myanmar in 1997 to that in 2002?
Your response must be concise. 1.22. What is the ratio of the Aid flow (current US$) of Cameroon in 1997 to that in 2003?
Your answer should be compact. 0.69. What is the ratio of the Aid flow (current US$) in Hungary in 1997 to that in 2003?
Provide a short and direct response. 1.17. What is the ratio of the Aid flow (current US$) in Lao PDR in 1997 to that in 2003?
Make the answer very short. 0.8. What is the ratio of the Aid flow (current US$) in Myanmar in 1997 to that in 2003?
Offer a very short reply. 1.53. What is the ratio of the Aid flow (current US$) of Cameroon in 1998 to that in 1999?
Give a very brief answer. 1.13. What is the ratio of the Aid flow (current US$) in Hungary in 1998 to that in 1999?
Offer a very short reply. 5.07. What is the ratio of the Aid flow (current US$) of Lao PDR in 1998 to that in 1999?
Provide a succinct answer. 1.09. What is the ratio of the Aid flow (current US$) in Myanmar in 1998 to that in 1999?
Ensure brevity in your answer.  1.12. What is the ratio of the Aid flow (current US$) in Cameroon in 1998 to that in 2000?
Your answer should be compact. 1.77. What is the ratio of the Aid flow (current US$) of Hungary in 1998 to that in 2000?
Make the answer very short. 7. What is the ratio of the Aid flow (current US$) in Lao PDR in 1998 to that in 2000?
Your response must be concise. 0.91. What is the ratio of the Aid flow (current US$) in Myanmar in 1998 to that in 2000?
Keep it short and to the point. 1.56. What is the ratio of the Aid flow (current US$) in Cameroon in 1998 to that in 2001?
Ensure brevity in your answer.  2.58. What is the ratio of the Aid flow (current US$) of Hungary in 1998 to that in 2001?
Your answer should be very brief. 7.62. What is the ratio of the Aid flow (current US$) in Lao PDR in 1998 to that in 2001?
Provide a short and direct response. 1.09. What is the ratio of the Aid flow (current US$) in Myanmar in 1998 to that in 2001?
Provide a succinct answer. 1.52. What is the ratio of the Aid flow (current US$) in Cameroon in 1998 to that in 2002?
Your answer should be compact. 1.28. What is the ratio of the Aid flow (current US$) of Hungary in 1998 to that in 2002?
Your answer should be very brief. 5.94. What is the ratio of the Aid flow (current US$) of Lao PDR in 1998 to that in 2002?
Offer a very short reply. 0.79. What is the ratio of the Aid flow (current US$) of Myanmar in 1998 to that in 2002?
Your answer should be compact. 1.19. What is the ratio of the Aid flow (current US$) in Cameroon in 1998 to that in 2003?
Provide a succinct answer. 0.53. What is the ratio of the Aid flow (current US$) in Hungary in 1998 to that in 2003?
Ensure brevity in your answer.  4.66. What is the ratio of the Aid flow (current US$) in Lao PDR in 1998 to that in 2003?
Your answer should be compact. 0.63. What is the ratio of the Aid flow (current US$) of Myanmar in 1998 to that in 2003?
Offer a terse response. 1.5. What is the ratio of the Aid flow (current US$) of Cameroon in 1999 to that in 2000?
Your answer should be very brief. 1.56. What is the ratio of the Aid flow (current US$) in Hungary in 1999 to that in 2000?
Ensure brevity in your answer.  1.38. What is the ratio of the Aid flow (current US$) of Lao PDR in 1999 to that in 2000?
Offer a terse response. 0.84. What is the ratio of the Aid flow (current US$) in Myanmar in 1999 to that in 2000?
Your answer should be very brief. 1.39. What is the ratio of the Aid flow (current US$) of Cameroon in 1999 to that in 2001?
Your answer should be very brief. 2.27. What is the ratio of the Aid flow (current US$) in Hungary in 1999 to that in 2001?
Provide a short and direct response. 1.5. What is the ratio of the Aid flow (current US$) in Lao PDR in 1999 to that in 2001?
Your answer should be very brief. 1. What is the ratio of the Aid flow (current US$) in Myanmar in 1999 to that in 2001?
Provide a succinct answer. 1.35. What is the ratio of the Aid flow (current US$) in Cameroon in 1999 to that in 2002?
Your answer should be compact. 1.13. What is the ratio of the Aid flow (current US$) in Hungary in 1999 to that in 2002?
Provide a succinct answer. 1.17. What is the ratio of the Aid flow (current US$) in Lao PDR in 1999 to that in 2002?
Your answer should be compact. 0.72. What is the ratio of the Aid flow (current US$) of Myanmar in 1999 to that in 2002?
Ensure brevity in your answer.  1.06. What is the ratio of the Aid flow (current US$) in Cameroon in 1999 to that in 2003?
Ensure brevity in your answer.  0.46. What is the ratio of the Aid flow (current US$) of Hungary in 1999 to that in 2003?
Keep it short and to the point. 0.92. What is the ratio of the Aid flow (current US$) of Lao PDR in 1999 to that in 2003?
Offer a very short reply. 0.58. What is the ratio of the Aid flow (current US$) in Myanmar in 1999 to that in 2003?
Your answer should be compact. 1.33. What is the ratio of the Aid flow (current US$) of Cameroon in 2000 to that in 2001?
Keep it short and to the point. 1.45. What is the ratio of the Aid flow (current US$) of Hungary in 2000 to that in 2001?
Provide a short and direct response. 1.09. What is the ratio of the Aid flow (current US$) in Lao PDR in 2000 to that in 2001?
Keep it short and to the point. 1.19. What is the ratio of the Aid flow (current US$) in Myanmar in 2000 to that in 2001?
Give a very brief answer. 0.97. What is the ratio of the Aid flow (current US$) in Cameroon in 2000 to that in 2002?
Your answer should be compact. 0.72. What is the ratio of the Aid flow (current US$) in Hungary in 2000 to that in 2002?
Offer a terse response. 0.85. What is the ratio of the Aid flow (current US$) in Lao PDR in 2000 to that in 2002?
Provide a short and direct response. 0.86. What is the ratio of the Aid flow (current US$) in Myanmar in 2000 to that in 2002?
Ensure brevity in your answer.  0.76. What is the ratio of the Aid flow (current US$) in Cameroon in 2000 to that in 2003?
Your answer should be compact. 0.3. What is the ratio of the Aid flow (current US$) of Hungary in 2000 to that in 2003?
Offer a very short reply. 0.67. What is the ratio of the Aid flow (current US$) of Lao PDR in 2000 to that in 2003?
Give a very brief answer. 0.69. What is the ratio of the Aid flow (current US$) in Myanmar in 2000 to that in 2003?
Provide a succinct answer. 0.96. What is the ratio of the Aid flow (current US$) in Cameroon in 2001 to that in 2002?
Your answer should be very brief. 0.5. What is the ratio of the Aid flow (current US$) in Hungary in 2001 to that in 2002?
Your answer should be very brief. 0.78. What is the ratio of the Aid flow (current US$) in Lao PDR in 2001 to that in 2002?
Your answer should be compact. 0.72. What is the ratio of the Aid flow (current US$) in Myanmar in 2001 to that in 2002?
Make the answer very short. 0.78. What is the ratio of the Aid flow (current US$) of Cameroon in 2001 to that in 2003?
Ensure brevity in your answer.  0.2. What is the ratio of the Aid flow (current US$) of Hungary in 2001 to that in 2003?
Provide a succinct answer. 0.61. What is the ratio of the Aid flow (current US$) in Lao PDR in 2001 to that in 2003?
Your response must be concise. 0.58. What is the ratio of the Aid flow (current US$) of Myanmar in 2001 to that in 2003?
Your answer should be compact. 0.98. What is the ratio of the Aid flow (current US$) in Cameroon in 2002 to that in 2003?
Give a very brief answer. 0.41. What is the ratio of the Aid flow (current US$) in Hungary in 2002 to that in 2003?
Your response must be concise. 0.78. What is the ratio of the Aid flow (current US$) in Lao PDR in 2002 to that in 2003?
Your answer should be compact. 0.8. What is the ratio of the Aid flow (current US$) of Myanmar in 2002 to that in 2003?
Give a very brief answer. 1.26. What is the difference between the highest and the second highest Aid flow (current US$) of Cameroon?
Provide a succinct answer. 9.08e+07. What is the difference between the highest and the second highest Aid flow (current US$) in Hungary?
Provide a succinct answer. 3.33e+07. What is the difference between the highest and the second highest Aid flow (current US$) of Lao PDR?
Ensure brevity in your answer.  3.61e+06. What is the difference between the highest and the second highest Aid flow (current US$) of Myanmar?
Provide a succinct answer. 4.00e+04. What is the difference between the highest and the lowest Aid flow (current US$) in Cameroon?
Your answer should be compact. 2.31e+08. What is the difference between the highest and the lowest Aid flow (current US$) in Hungary?
Offer a terse response. 3.86e+07. What is the difference between the highest and the lowest Aid flow (current US$) in Lao PDR?
Offer a terse response. 7.78e+06. What is the difference between the highest and the lowest Aid flow (current US$) in Myanmar?
Provide a short and direct response. 6.90e+05. 